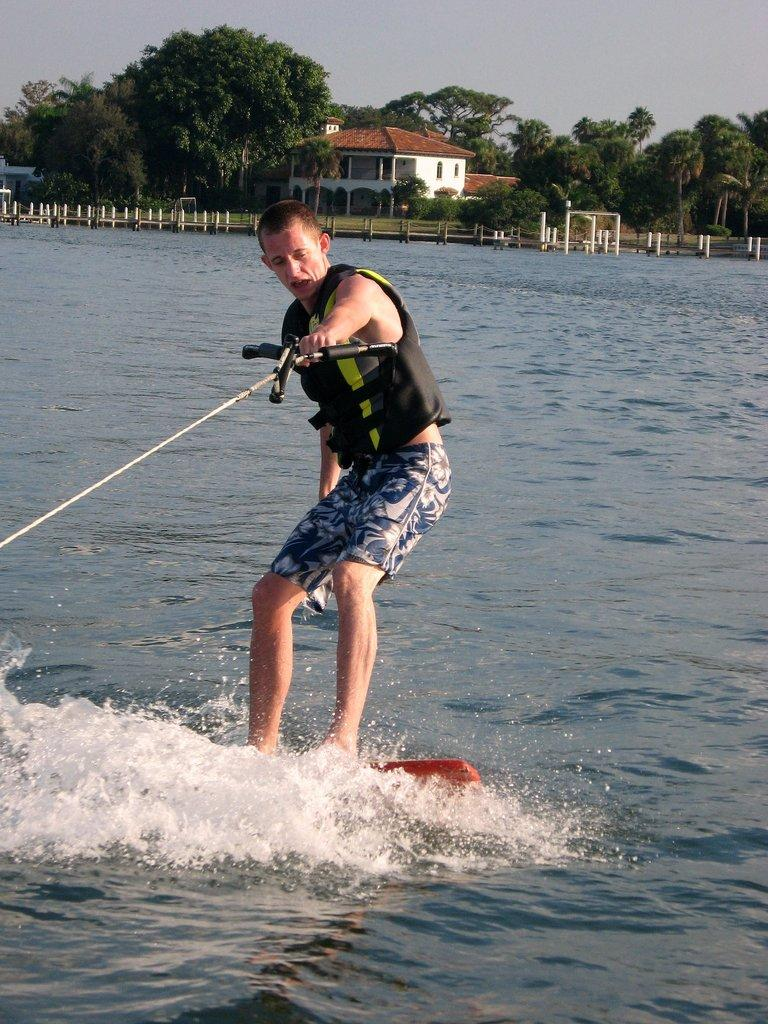What is the person in the image doing? The person is riding a surfing board in the image. Where is the surfing board located? The surfing board is on a lake in the image. What can be seen in the sky in the image? The sky is visible in the image. What type of vegetation is present in the image? There are trees in the image. What type of structure can be seen in the image? There is a building in the image. What type of cabbage is being used as a surfboard in the image? There is no cabbage present in the image; the person is riding a surfing board made of a different material. Is there any beef visible in the image? There is no beef present in the image. 